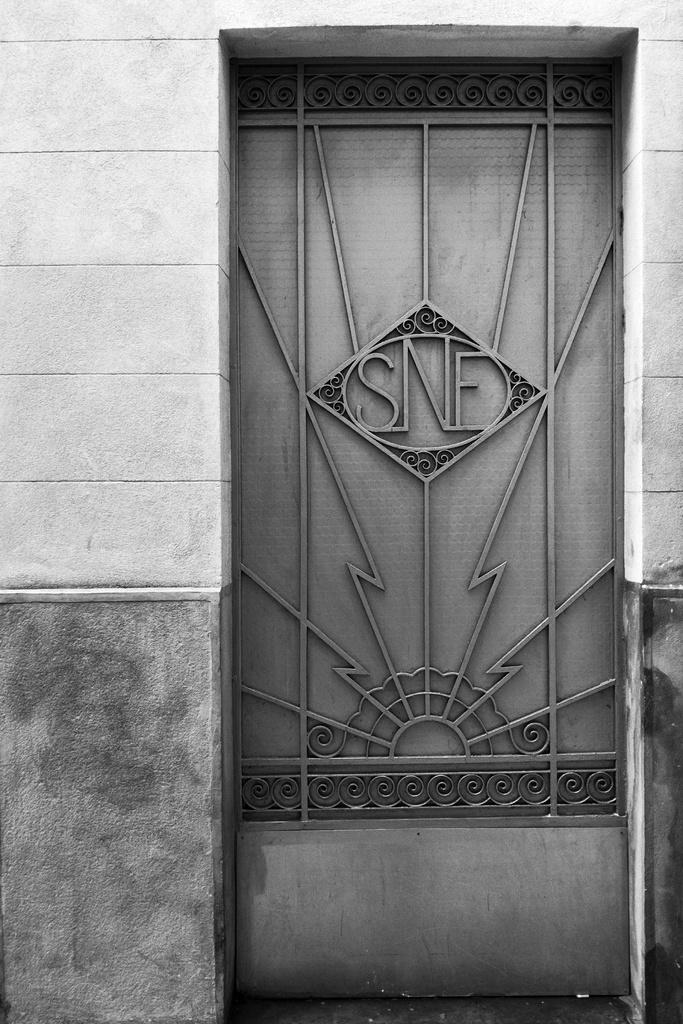What type of material is used to construct the gate in the image? The gate is made up of metal in the image. Can you describe the design of the gate? The gate has thin metal rods. What is located beside the gate in the image? There is a wall beside the gate in the image. What type of feast is being prepared behind the gate in the image? There is no indication of a feast or any preparations in the image; it only shows a gate made up of metal with thin metal rods and a wall beside it. 